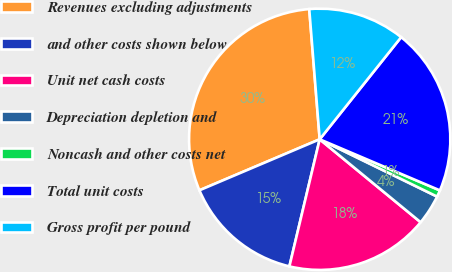Convert chart to OTSL. <chart><loc_0><loc_0><loc_500><loc_500><pie_chart><fcel>Revenues excluding adjustments<fcel>and other costs shown below<fcel>Unit net cash costs<fcel>Depreciation depletion and<fcel>Noncash and other costs net<fcel>Total unit costs<fcel>Gross profit per pound<nl><fcel>30.11%<fcel>14.89%<fcel>17.78%<fcel>3.72%<fcel>0.83%<fcel>20.68%<fcel>11.99%<nl></chart> 